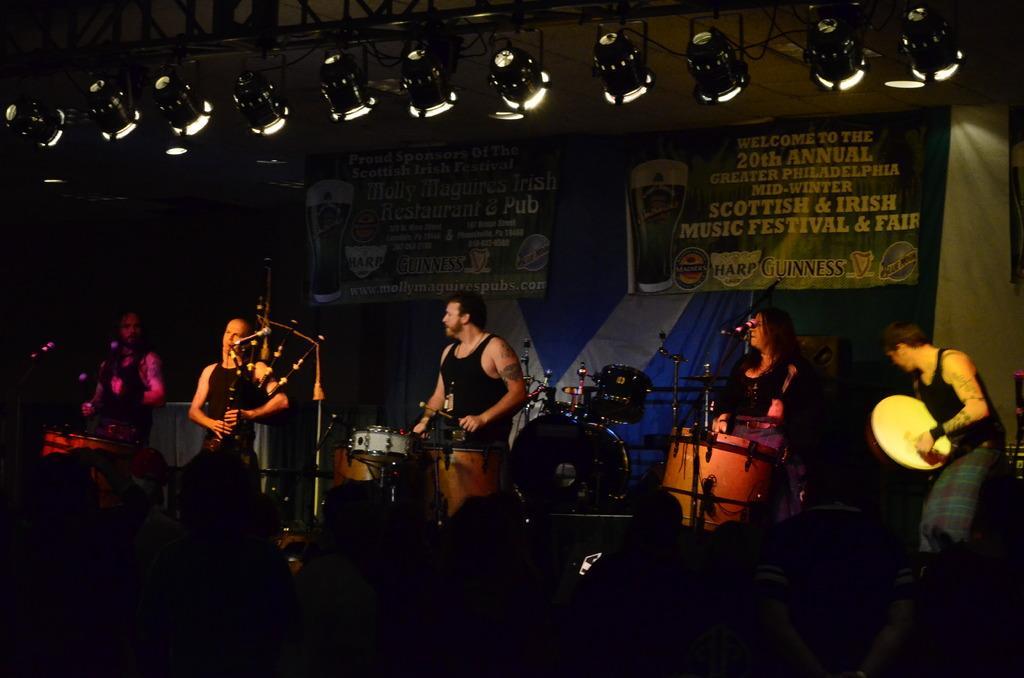How would you summarize this image in a sentence or two? In this image I can see on the left side a woman is playing the bagpipes. In the middle a man is beating the drums, at the top there are banners on this stage and there are lights. 